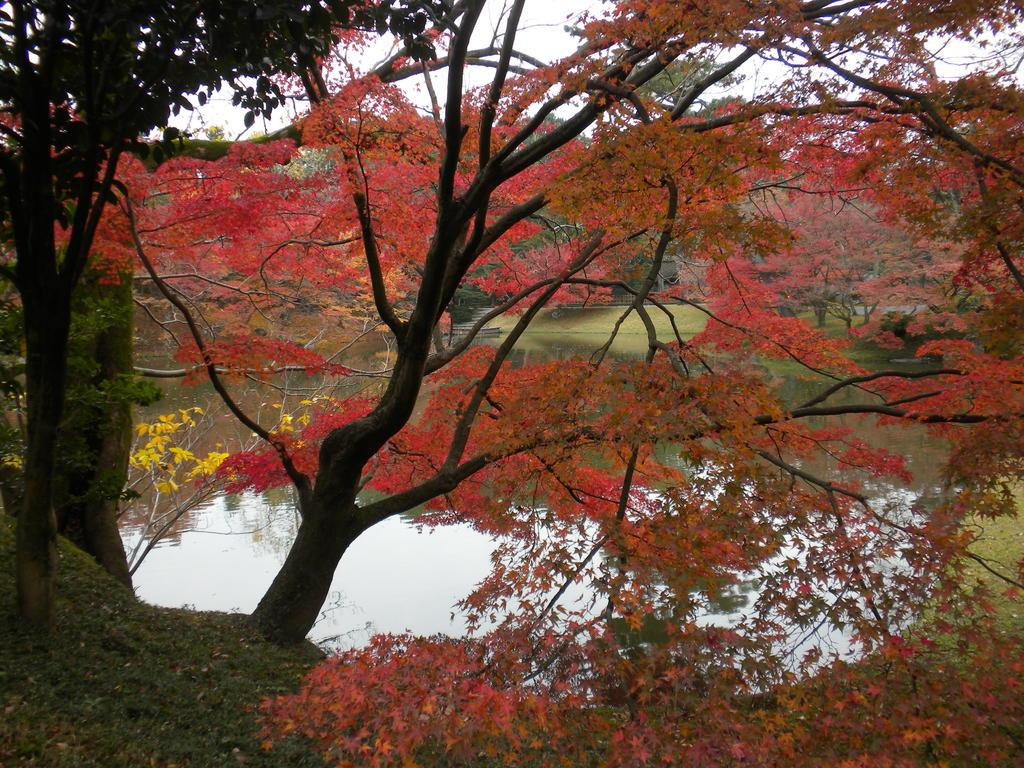What type of vegetation is present in the image? There are trees with branches and leaves in the image. What colors are the leaves on the trees? The leaves are red and yellow in color. What type of ground cover is visible in the image? There is grass visible in the image. What natural element is also present in the image? There is water visible in the image. What type of print can be seen on the side of the tree in the image? There is no print visible on the trees in the image; they are natural and do not have any text or design. 